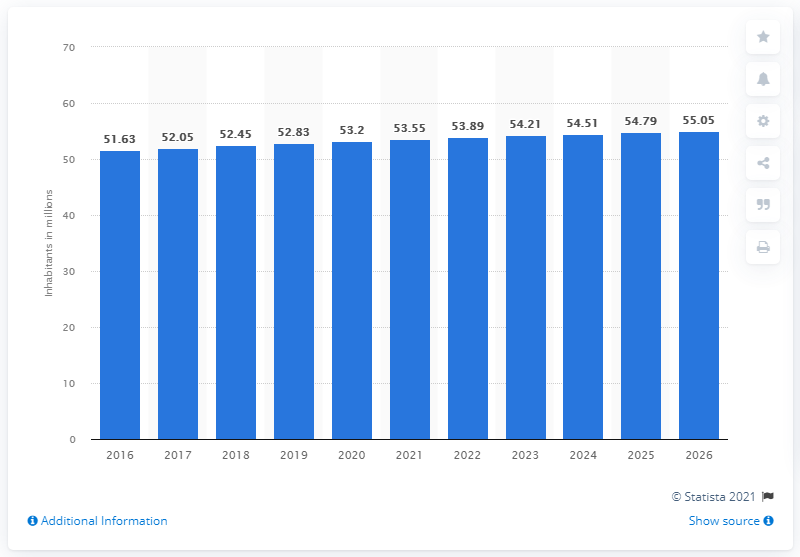Outline some significant characteristics in this image. In 2020, the population of Burma was approximately 53.55 million. 